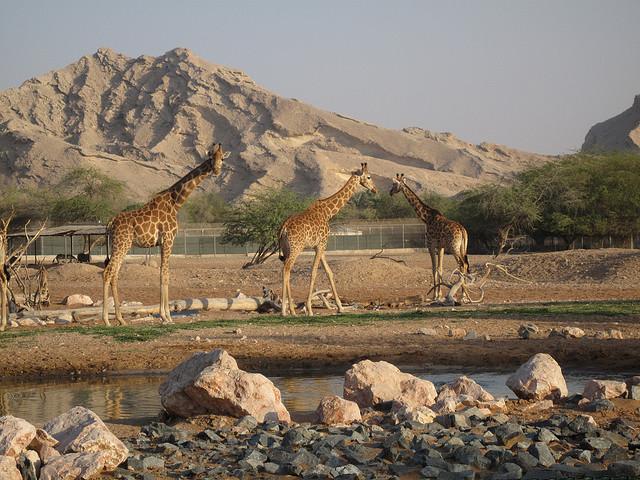What kind of animal is this?
Write a very short answer. Giraffe. What kind of trees are visible?
Give a very brief answer. Green. What are these?
Short answer required. Giraffes. Is this animal alone?
Write a very short answer. No. Are the animals in their natural habitat?
Short answer required. No. What animal is pictured?
Be succinct. Giraffe. Is the mountain terrain smooth or rocky?
Concise answer only. Rocky. 